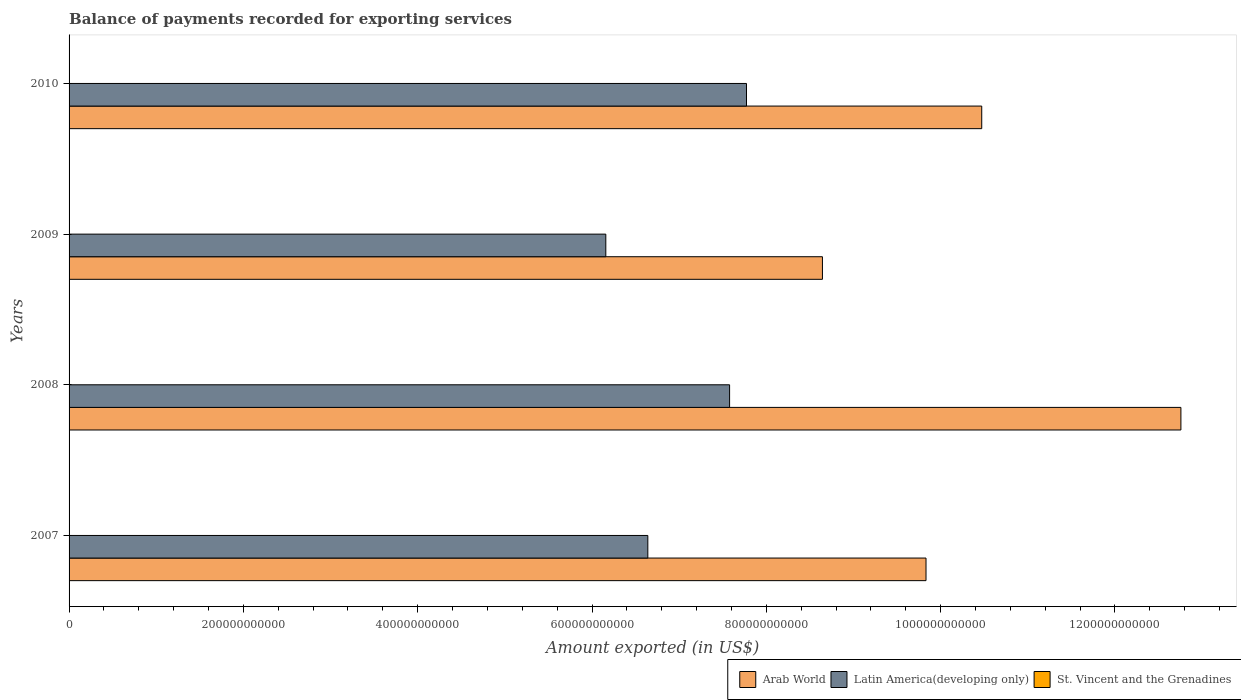How many groups of bars are there?
Offer a terse response. 4. Are the number of bars per tick equal to the number of legend labels?
Your response must be concise. Yes. How many bars are there on the 1st tick from the top?
Keep it short and to the point. 3. How many bars are there on the 1st tick from the bottom?
Your response must be concise. 3. In how many cases, is the number of bars for a given year not equal to the number of legend labels?
Make the answer very short. 0. What is the amount exported in St. Vincent and the Grenadines in 2010?
Your answer should be compact. 1.96e+08. Across all years, what is the maximum amount exported in Latin America(developing only)?
Your response must be concise. 7.77e+11. Across all years, what is the minimum amount exported in Latin America(developing only)?
Your answer should be compact. 6.16e+11. In which year was the amount exported in St. Vincent and the Grenadines minimum?
Your answer should be very brief. 2010. What is the total amount exported in Arab World in the graph?
Your answer should be very brief. 4.17e+12. What is the difference between the amount exported in Latin America(developing only) in 2007 and that in 2009?
Provide a succinct answer. 4.82e+1. What is the difference between the amount exported in St. Vincent and the Grenadines in 2008 and the amount exported in Latin America(developing only) in 2007?
Offer a terse response. -6.64e+11. What is the average amount exported in Arab World per year?
Your answer should be compact. 1.04e+12. In the year 2007, what is the difference between the amount exported in St. Vincent and the Grenadines and amount exported in Latin America(developing only)?
Offer a terse response. -6.64e+11. What is the ratio of the amount exported in Latin America(developing only) in 2008 to that in 2010?
Provide a short and direct response. 0.98. Is the amount exported in Latin America(developing only) in 2008 less than that in 2010?
Your answer should be compact. Yes. Is the difference between the amount exported in St. Vincent and the Grenadines in 2009 and 2010 greater than the difference between the amount exported in Latin America(developing only) in 2009 and 2010?
Your answer should be compact. Yes. What is the difference between the highest and the second highest amount exported in St. Vincent and the Grenadines?
Your answer should be compact. 5.34e+06. What is the difference between the highest and the lowest amount exported in Arab World?
Provide a succinct answer. 4.11e+11. What does the 3rd bar from the top in 2007 represents?
Keep it short and to the point. Arab World. What does the 1st bar from the bottom in 2008 represents?
Provide a short and direct response. Arab World. Is it the case that in every year, the sum of the amount exported in St. Vincent and the Grenadines and amount exported in Latin America(developing only) is greater than the amount exported in Arab World?
Give a very brief answer. No. Are all the bars in the graph horizontal?
Offer a terse response. Yes. What is the difference between two consecutive major ticks on the X-axis?
Offer a terse response. 2.00e+11. Are the values on the major ticks of X-axis written in scientific E-notation?
Offer a terse response. No. How are the legend labels stacked?
Make the answer very short. Horizontal. What is the title of the graph?
Offer a terse response. Balance of payments recorded for exporting services. Does "Bahrain" appear as one of the legend labels in the graph?
Offer a very short reply. No. What is the label or title of the X-axis?
Provide a succinct answer. Amount exported (in US$). What is the label or title of the Y-axis?
Your response must be concise. Years. What is the Amount exported (in US$) in Arab World in 2007?
Your answer should be compact. 9.83e+11. What is the Amount exported (in US$) in Latin America(developing only) in 2007?
Provide a short and direct response. 6.64e+11. What is the Amount exported (in US$) in St. Vincent and the Grenadines in 2007?
Your answer should be compact. 2.26e+08. What is the Amount exported (in US$) of Arab World in 2008?
Give a very brief answer. 1.28e+12. What is the Amount exported (in US$) of Latin America(developing only) in 2008?
Your answer should be compact. 7.58e+11. What is the Amount exported (in US$) in St. Vincent and the Grenadines in 2008?
Your response must be concise. 2.20e+08. What is the Amount exported (in US$) of Arab World in 2009?
Ensure brevity in your answer.  8.64e+11. What is the Amount exported (in US$) of Latin America(developing only) in 2009?
Provide a short and direct response. 6.16e+11. What is the Amount exported (in US$) of St. Vincent and the Grenadines in 2009?
Your answer should be compact. 2.06e+08. What is the Amount exported (in US$) of Arab World in 2010?
Offer a very short reply. 1.05e+12. What is the Amount exported (in US$) in Latin America(developing only) in 2010?
Offer a terse response. 7.77e+11. What is the Amount exported (in US$) of St. Vincent and the Grenadines in 2010?
Offer a terse response. 1.96e+08. Across all years, what is the maximum Amount exported (in US$) in Arab World?
Offer a very short reply. 1.28e+12. Across all years, what is the maximum Amount exported (in US$) of Latin America(developing only)?
Your response must be concise. 7.77e+11. Across all years, what is the maximum Amount exported (in US$) in St. Vincent and the Grenadines?
Give a very brief answer. 2.26e+08. Across all years, what is the minimum Amount exported (in US$) in Arab World?
Your answer should be compact. 8.64e+11. Across all years, what is the minimum Amount exported (in US$) of Latin America(developing only)?
Provide a short and direct response. 6.16e+11. Across all years, what is the minimum Amount exported (in US$) of St. Vincent and the Grenadines?
Your answer should be compact. 1.96e+08. What is the total Amount exported (in US$) in Arab World in the graph?
Offer a very short reply. 4.17e+12. What is the total Amount exported (in US$) in Latin America(developing only) in the graph?
Give a very brief answer. 2.81e+12. What is the total Amount exported (in US$) in St. Vincent and the Grenadines in the graph?
Your answer should be compact. 8.48e+08. What is the difference between the Amount exported (in US$) in Arab World in 2007 and that in 2008?
Keep it short and to the point. -2.92e+11. What is the difference between the Amount exported (in US$) in Latin America(developing only) in 2007 and that in 2008?
Provide a short and direct response. -9.38e+1. What is the difference between the Amount exported (in US$) of St. Vincent and the Grenadines in 2007 and that in 2008?
Keep it short and to the point. 5.34e+06. What is the difference between the Amount exported (in US$) of Arab World in 2007 and that in 2009?
Make the answer very short. 1.19e+11. What is the difference between the Amount exported (in US$) in Latin America(developing only) in 2007 and that in 2009?
Your answer should be very brief. 4.82e+1. What is the difference between the Amount exported (in US$) of St. Vincent and the Grenadines in 2007 and that in 2009?
Make the answer very short. 1.96e+07. What is the difference between the Amount exported (in US$) in Arab World in 2007 and that in 2010?
Your answer should be compact. -6.39e+1. What is the difference between the Amount exported (in US$) in Latin America(developing only) in 2007 and that in 2010?
Offer a terse response. -1.13e+11. What is the difference between the Amount exported (in US$) of St. Vincent and the Grenadines in 2007 and that in 2010?
Offer a terse response. 2.98e+07. What is the difference between the Amount exported (in US$) of Arab World in 2008 and that in 2009?
Make the answer very short. 4.11e+11. What is the difference between the Amount exported (in US$) in Latin America(developing only) in 2008 and that in 2009?
Offer a terse response. 1.42e+11. What is the difference between the Amount exported (in US$) of St. Vincent and the Grenadines in 2008 and that in 2009?
Offer a terse response. 1.43e+07. What is the difference between the Amount exported (in US$) in Arab World in 2008 and that in 2010?
Offer a very short reply. 2.29e+11. What is the difference between the Amount exported (in US$) in Latin America(developing only) in 2008 and that in 2010?
Offer a very short reply. -1.94e+1. What is the difference between the Amount exported (in US$) of St. Vincent and the Grenadines in 2008 and that in 2010?
Offer a terse response. 2.44e+07. What is the difference between the Amount exported (in US$) in Arab World in 2009 and that in 2010?
Offer a very short reply. -1.83e+11. What is the difference between the Amount exported (in US$) in Latin America(developing only) in 2009 and that in 2010?
Your answer should be very brief. -1.61e+11. What is the difference between the Amount exported (in US$) of St. Vincent and the Grenadines in 2009 and that in 2010?
Keep it short and to the point. 1.01e+07. What is the difference between the Amount exported (in US$) of Arab World in 2007 and the Amount exported (in US$) of Latin America(developing only) in 2008?
Make the answer very short. 2.25e+11. What is the difference between the Amount exported (in US$) in Arab World in 2007 and the Amount exported (in US$) in St. Vincent and the Grenadines in 2008?
Give a very brief answer. 9.83e+11. What is the difference between the Amount exported (in US$) in Latin America(developing only) in 2007 and the Amount exported (in US$) in St. Vincent and the Grenadines in 2008?
Offer a very short reply. 6.64e+11. What is the difference between the Amount exported (in US$) in Arab World in 2007 and the Amount exported (in US$) in Latin America(developing only) in 2009?
Make the answer very short. 3.67e+11. What is the difference between the Amount exported (in US$) in Arab World in 2007 and the Amount exported (in US$) in St. Vincent and the Grenadines in 2009?
Your answer should be very brief. 9.83e+11. What is the difference between the Amount exported (in US$) in Latin America(developing only) in 2007 and the Amount exported (in US$) in St. Vincent and the Grenadines in 2009?
Offer a very short reply. 6.64e+11. What is the difference between the Amount exported (in US$) in Arab World in 2007 and the Amount exported (in US$) in Latin America(developing only) in 2010?
Offer a terse response. 2.06e+11. What is the difference between the Amount exported (in US$) in Arab World in 2007 and the Amount exported (in US$) in St. Vincent and the Grenadines in 2010?
Ensure brevity in your answer.  9.83e+11. What is the difference between the Amount exported (in US$) in Latin America(developing only) in 2007 and the Amount exported (in US$) in St. Vincent and the Grenadines in 2010?
Ensure brevity in your answer.  6.64e+11. What is the difference between the Amount exported (in US$) in Arab World in 2008 and the Amount exported (in US$) in Latin America(developing only) in 2009?
Keep it short and to the point. 6.60e+11. What is the difference between the Amount exported (in US$) in Arab World in 2008 and the Amount exported (in US$) in St. Vincent and the Grenadines in 2009?
Offer a very short reply. 1.28e+12. What is the difference between the Amount exported (in US$) in Latin America(developing only) in 2008 and the Amount exported (in US$) in St. Vincent and the Grenadines in 2009?
Give a very brief answer. 7.58e+11. What is the difference between the Amount exported (in US$) of Arab World in 2008 and the Amount exported (in US$) of Latin America(developing only) in 2010?
Your response must be concise. 4.98e+11. What is the difference between the Amount exported (in US$) in Arab World in 2008 and the Amount exported (in US$) in St. Vincent and the Grenadines in 2010?
Provide a short and direct response. 1.28e+12. What is the difference between the Amount exported (in US$) in Latin America(developing only) in 2008 and the Amount exported (in US$) in St. Vincent and the Grenadines in 2010?
Your answer should be compact. 7.58e+11. What is the difference between the Amount exported (in US$) in Arab World in 2009 and the Amount exported (in US$) in Latin America(developing only) in 2010?
Offer a very short reply. 8.71e+1. What is the difference between the Amount exported (in US$) of Arab World in 2009 and the Amount exported (in US$) of St. Vincent and the Grenadines in 2010?
Make the answer very short. 8.64e+11. What is the difference between the Amount exported (in US$) of Latin America(developing only) in 2009 and the Amount exported (in US$) of St. Vincent and the Grenadines in 2010?
Your answer should be compact. 6.16e+11. What is the average Amount exported (in US$) of Arab World per year?
Offer a terse response. 1.04e+12. What is the average Amount exported (in US$) of Latin America(developing only) per year?
Provide a short and direct response. 7.04e+11. What is the average Amount exported (in US$) in St. Vincent and the Grenadines per year?
Your answer should be very brief. 2.12e+08. In the year 2007, what is the difference between the Amount exported (in US$) in Arab World and Amount exported (in US$) in Latin America(developing only)?
Your answer should be very brief. 3.19e+11. In the year 2007, what is the difference between the Amount exported (in US$) in Arab World and Amount exported (in US$) in St. Vincent and the Grenadines?
Provide a short and direct response. 9.83e+11. In the year 2007, what is the difference between the Amount exported (in US$) of Latin America(developing only) and Amount exported (in US$) of St. Vincent and the Grenadines?
Provide a succinct answer. 6.64e+11. In the year 2008, what is the difference between the Amount exported (in US$) of Arab World and Amount exported (in US$) of Latin America(developing only)?
Give a very brief answer. 5.18e+11. In the year 2008, what is the difference between the Amount exported (in US$) of Arab World and Amount exported (in US$) of St. Vincent and the Grenadines?
Keep it short and to the point. 1.28e+12. In the year 2008, what is the difference between the Amount exported (in US$) in Latin America(developing only) and Amount exported (in US$) in St. Vincent and the Grenadines?
Keep it short and to the point. 7.58e+11. In the year 2009, what is the difference between the Amount exported (in US$) in Arab World and Amount exported (in US$) in Latin America(developing only)?
Ensure brevity in your answer.  2.49e+11. In the year 2009, what is the difference between the Amount exported (in US$) in Arab World and Amount exported (in US$) in St. Vincent and the Grenadines?
Keep it short and to the point. 8.64e+11. In the year 2009, what is the difference between the Amount exported (in US$) in Latin America(developing only) and Amount exported (in US$) in St. Vincent and the Grenadines?
Keep it short and to the point. 6.16e+11. In the year 2010, what is the difference between the Amount exported (in US$) of Arab World and Amount exported (in US$) of Latin America(developing only)?
Provide a succinct answer. 2.70e+11. In the year 2010, what is the difference between the Amount exported (in US$) in Arab World and Amount exported (in US$) in St. Vincent and the Grenadines?
Make the answer very short. 1.05e+12. In the year 2010, what is the difference between the Amount exported (in US$) of Latin America(developing only) and Amount exported (in US$) of St. Vincent and the Grenadines?
Offer a terse response. 7.77e+11. What is the ratio of the Amount exported (in US$) of Arab World in 2007 to that in 2008?
Your answer should be compact. 0.77. What is the ratio of the Amount exported (in US$) of Latin America(developing only) in 2007 to that in 2008?
Provide a short and direct response. 0.88. What is the ratio of the Amount exported (in US$) in St. Vincent and the Grenadines in 2007 to that in 2008?
Keep it short and to the point. 1.02. What is the ratio of the Amount exported (in US$) of Arab World in 2007 to that in 2009?
Give a very brief answer. 1.14. What is the ratio of the Amount exported (in US$) in Latin America(developing only) in 2007 to that in 2009?
Your response must be concise. 1.08. What is the ratio of the Amount exported (in US$) in St. Vincent and the Grenadines in 2007 to that in 2009?
Your response must be concise. 1.1. What is the ratio of the Amount exported (in US$) in Arab World in 2007 to that in 2010?
Make the answer very short. 0.94. What is the ratio of the Amount exported (in US$) of Latin America(developing only) in 2007 to that in 2010?
Your answer should be very brief. 0.85. What is the ratio of the Amount exported (in US$) in St. Vincent and the Grenadines in 2007 to that in 2010?
Provide a short and direct response. 1.15. What is the ratio of the Amount exported (in US$) of Arab World in 2008 to that in 2009?
Provide a short and direct response. 1.48. What is the ratio of the Amount exported (in US$) of Latin America(developing only) in 2008 to that in 2009?
Make the answer very short. 1.23. What is the ratio of the Amount exported (in US$) of St. Vincent and the Grenadines in 2008 to that in 2009?
Ensure brevity in your answer.  1.07. What is the ratio of the Amount exported (in US$) in Arab World in 2008 to that in 2010?
Your answer should be very brief. 1.22. What is the ratio of the Amount exported (in US$) of Latin America(developing only) in 2008 to that in 2010?
Provide a short and direct response. 0.97. What is the ratio of the Amount exported (in US$) in St. Vincent and the Grenadines in 2008 to that in 2010?
Your response must be concise. 1.12. What is the ratio of the Amount exported (in US$) in Arab World in 2009 to that in 2010?
Offer a terse response. 0.83. What is the ratio of the Amount exported (in US$) in Latin America(developing only) in 2009 to that in 2010?
Ensure brevity in your answer.  0.79. What is the ratio of the Amount exported (in US$) of St. Vincent and the Grenadines in 2009 to that in 2010?
Provide a succinct answer. 1.05. What is the difference between the highest and the second highest Amount exported (in US$) in Arab World?
Offer a terse response. 2.29e+11. What is the difference between the highest and the second highest Amount exported (in US$) in Latin America(developing only)?
Your answer should be compact. 1.94e+1. What is the difference between the highest and the second highest Amount exported (in US$) of St. Vincent and the Grenadines?
Offer a terse response. 5.34e+06. What is the difference between the highest and the lowest Amount exported (in US$) of Arab World?
Your answer should be very brief. 4.11e+11. What is the difference between the highest and the lowest Amount exported (in US$) of Latin America(developing only)?
Make the answer very short. 1.61e+11. What is the difference between the highest and the lowest Amount exported (in US$) in St. Vincent and the Grenadines?
Offer a terse response. 2.98e+07. 